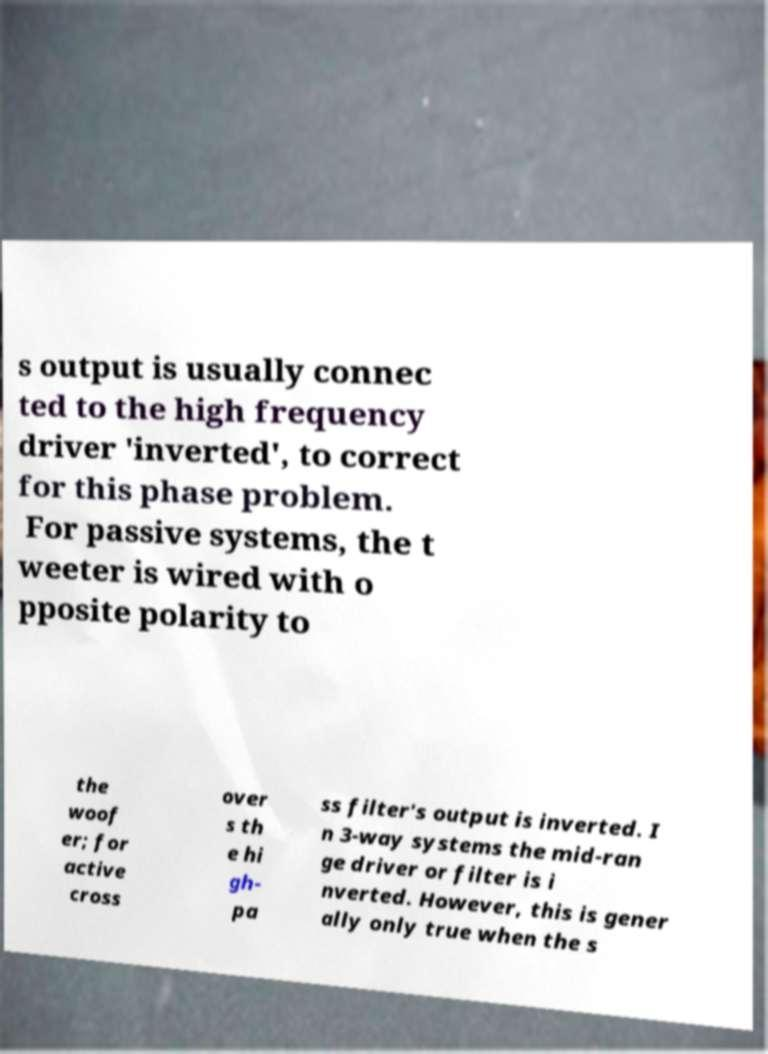There's text embedded in this image that I need extracted. Can you transcribe it verbatim? s output is usually connec ted to the high frequency driver 'inverted', to correct for this phase problem. For passive systems, the t weeter is wired with o pposite polarity to the woof er; for active cross over s th e hi gh- pa ss filter's output is inverted. I n 3-way systems the mid-ran ge driver or filter is i nverted. However, this is gener ally only true when the s 